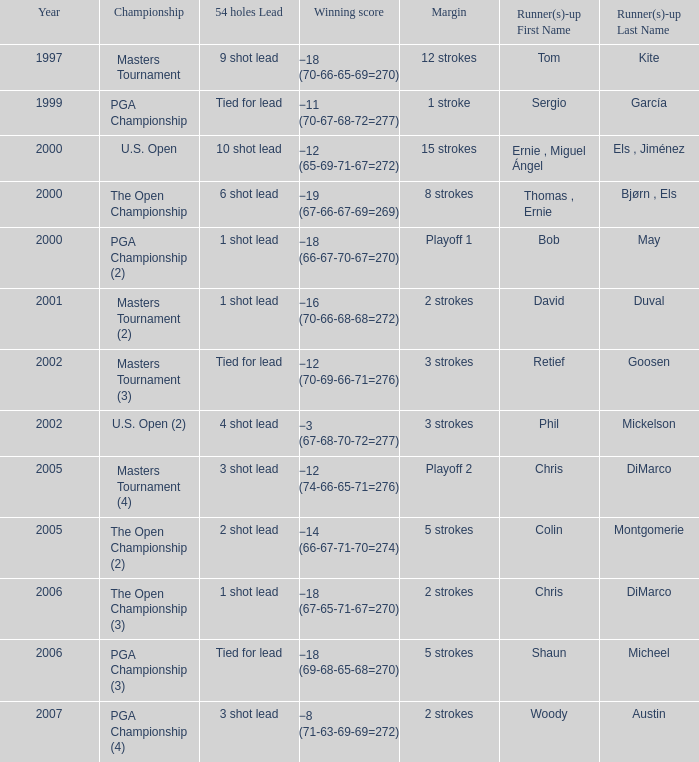 what's the margin where runner(s)-up is phil mickelson 3 strokes. 